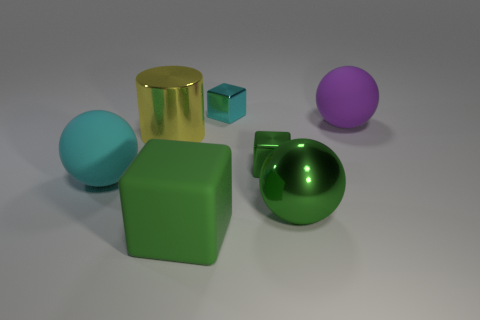There is a large matte object that is both in front of the cylinder and right of the yellow object; what shape is it?
Offer a very short reply. Cube. There is a cyan thing that is on the left side of the big cylinder; what is its size?
Offer a very short reply. Large. Does the cyan rubber ball have the same size as the green matte thing?
Your answer should be compact. Yes. Is the number of shiny cylinders that are to the left of the large green block less than the number of large green shiny spheres that are on the left side of the cyan ball?
Make the answer very short. No. There is a object that is in front of the tiny green metallic block and on the left side of the large rubber cube; what is its size?
Your response must be concise. Large. There is a big shiny thing that is in front of the large ball left of the matte block; is there a large purple ball left of it?
Offer a terse response. No. Are any small red shiny spheres visible?
Make the answer very short. No. Are there more cylinders behind the tiny cyan cube than small green shiny things in front of the big cyan rubber object?
Keep it short and to the point. No. What size is the cyan cube that is made of the same material as the yellow object?
Make the answer very short. Small. What size is the cyan thing left of the block that is behind the small metallic cube that is in front of the cyan metal object?
Your answer should be compact. Large. 